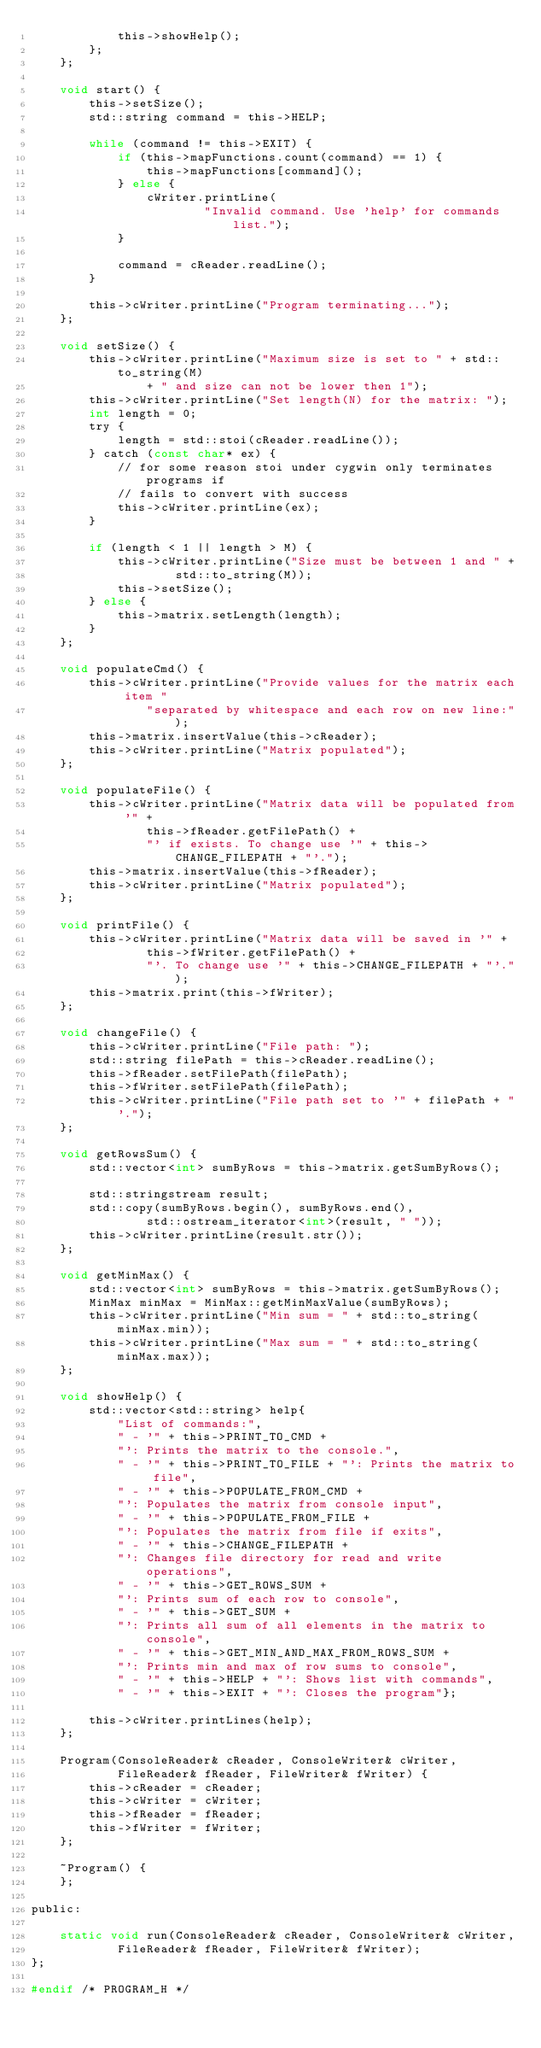<code> <loc_0><loc_0><loc_500><loc_500><_C_>            this->showHelp();
        };
    };

    void start() {
        this->setSize();
        std::string command = this->HELP;

        while (command != this->EXIT) {
            if (this->mapFunctions.count(command) == 1) {
                this->mapFunctions[command]();
            } else {
                cWriter.printLine(
                        "Invalid command. Use 'help' for commands list.");
            }

            command = cReader.readLine();
        }

        this->cWriter.printLine("Program terminating...");
    };

    void setSize() {
        this->cWriter.printLine("Maximum size is set to " + std::to_string(M)
                + " and size can not be lower then 1");
        this->cWriter.printLine("Set length(N) for the matrix: ");
        int length = 0;
        try {
            length = std::stoi(cReader.readLine());
        } catch (const char* ex) {
            // for some reason stoi under cygwin only terminates programs if
            // fails to convert with success
            this->cWriter.printLine(ex);
        }

        if (length < 1 || length > M) {
            this->cWriter.printLine("Size must be between 1 and " +
                    std::to_string(M));
            this->setSize();
        } else {
            this->matrix.setLength(length);
        }
    };

    void populateCmd() {
        this->cWriter.printLine("Provide values for the matrix each item "
                "separated by whitespace and each row on new line:");
        this->matrix.insertValue(this->cReader);
        this->cWriter.printLine("Matrix populated");
    };

    void populateFile() {
        this->cWriter.printLine("Matrix data will be populated from '" +
                this->fReader.getFilePath() +
                "' if exists. To change use '" + this->CHANGE_FILEPATH + "'.");
        this->matrix.insertValue(this->fReader);
        this->cWriter.printLine("Matrix populated");
    };

    void printFile() {
        this->cWriter.printLine("Matrix data will be saved in '" +
                this->fWriter.getFilePath() +
                "'. To change use '" + this->CHANGE_FILEPATH + "'.");
        this->matrix.print(this->fWriter);
    };

    void changeFile() {
        this->cWriter.printLine("File path: ");
        std::string filePath = this->cReader.readLine();
        this->fReader.setFilePath(filePath);
        this->fWriter.setFilePath(filePath);
        this->cWriter.printLine("File path set to '" + filePath + "'.");
    };

    void getRowsSum() {
        std::vector<int> sumByRows = this->matrix.getSumByRows();

        std::stringstream result;
        std::copy(sumByRows.begin(), sumByRows.end(),
                std::ostream_iterator<int>(result, " "));
        this->cWriter.printLine(result.str());
    };

    void getMinMax() {
        std::vector<int> sumByRows = this->matrix.getSumByRows();
        MinMax minMax = MinMax::getMinMaxValue(sumByRows);
        this->cWriter.printLine("Min sum = " + std::to_string(minMax.min));
        this->cWriter.printLine("Max sum = " + std::to_string(minMax.max));
    };

    void showHelp() {
        std::vector<std::string> help{
            "List of commands:",
            " - '" + this->PRINT_TO_CMD +
            "': Prints the matrix to the console.",
            " - '" + this->PRINT_TO_FILE + "': Prints the matrix to file",
            " - '" + this->POPULATE_FROM_CMD +
            "': Populates the matrix from console input",
            " - '" + this->POPULATE_FROM_FILE +
            "': Populates the matrix from file if exits",
            " - '" + this->CHANGE_FILEPATH +
            "': Changes file directory for read and write operations",
            " - '" + this->GET_ROWS_SUM +
            "': Prints sum of each row to console",
            " - '" + this->GET_SUM +
            "': Prints all sum of all elements in the matrix to console",
            " - '" + this->GET_MIN_AND_MAX_FROM_ROWS_SUM +
            "': Prints min and max of row sums to console",
            " - '" + this->HELP + "': Shows list with commands",
            " - '" + this->EXIT + "': Closes the program"};

        this->cWriter.printLines(help);
    };

    Program(ConsoleReader& cReader, ConsoleWriter& cWriter,
            FileReader& fReader, FileWriter& fWriter) {
        this->cReader = cReader;
        this->cWriter = cWriter;
        this->fReader = fReader;
        this->fWriter = fWriter;
    };

    ~Program() {
    };

public:

    static void run(ConsoleReader& cReader, ConsoleWriter& cWriter,
            FileReader& fReader, FileWriter& fWriter);
};

#endif /* PROGRAM_H */

</code> 